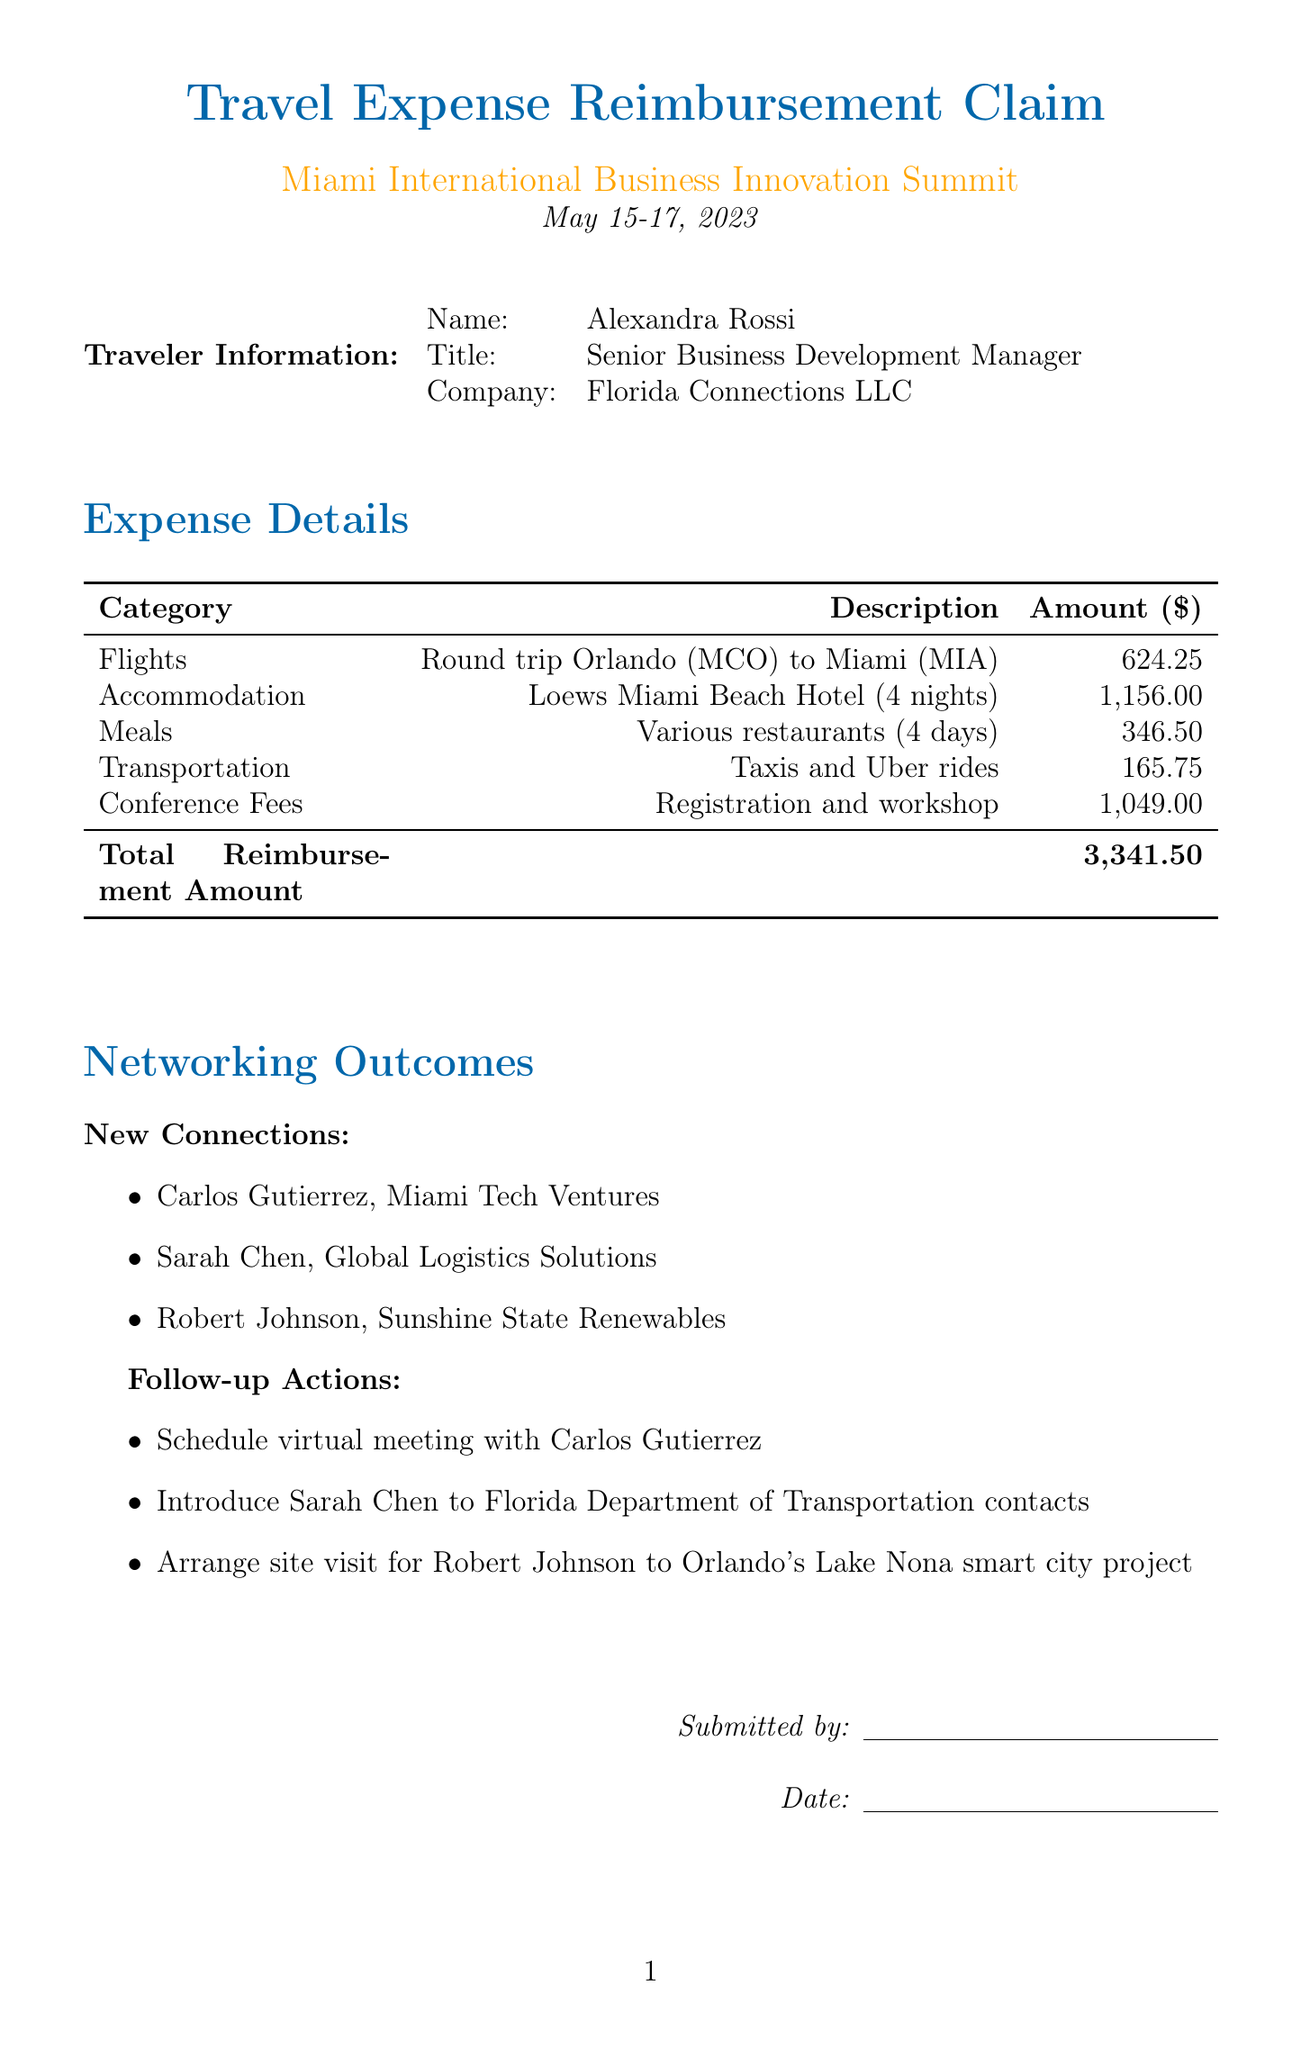What is the traveler's name? The traveler's name is stated in the document as Alexandra Rossi.
Answer: Alexandra Rossi What is the total reimbursement amount? The total reimbursement amount is clearly indicated in the summary of expenses.
Answer: 3,341.50 What hotel did the traveler stay at? The document specifies the name of the hotel where the traveler stayed as Loews Miami Beach Hotel.
Answer: Loews Miami Beach Hotel How many nights did the traveler stay in the hotel? The number of nights spent at the hotel is provided in the accommodation section of the document.
Answer: 4 What was the conference registration fee? The document lists the registration fee under the conference fees section.
Answer: 799.00 Who is one of the new connections made at the conference? The new connections are listed with their names and companies; one example can be extracted from this.
Answer: Carlos Gutierrez What are the follow-up actions proposed in the document? The document lists specific actions intended for follow-up as part of networking outcomes.
Answer: Schedule virtual meeting with Carlos Gutierrez What category has the highest total cost? The category with the highest total cost can be deduced by comparing the amounts listed for each expense category.
Answer: Conference Fees What restaurant did the traveler visit on May 15? The meals section provides details about dining locations and their corresponding dates.
Answer: Versailles Restaurant 